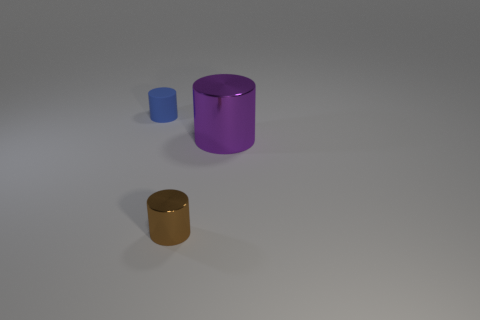Do the blue cylinder and the tiny brown cylinder have the same material?
Ensure brevity in your answer.  No. Is there another object made of the same material as the big purple thing?
Provide a short and direct response. Yes. What is the color of the metallic object that is in front of the metal cylinder behind the small cylinder that is in front of the big metallic thing?
Your response must be concise. Brown. How many red objects are either cubes or big shiny things?
Your answer should be very brief. 0. How many other brown objects are the same shape as the small rubber object?
Keep it short and to the point. 1. The brown metal object that is the same size as the rubber thing is what shape?
Make the answer very short. Cylinder. Are there any small brown metal cylinders in front of the blue matte thing?
Give a very brief answer. Yes. Is there a small blue matte cylinder right of the small cylinder that is left of the tiny brown metal cylinder?
Offer a very short reply. No. Is the number of purple things behind the purple shiny thing less than the number of tiny brown metallic objects on the right side of the small metallic cylinder?
Your response must be concise. No. Is there anything else that is the same size as the purple cylinder?
Ensure brevity in your answer.  No. 